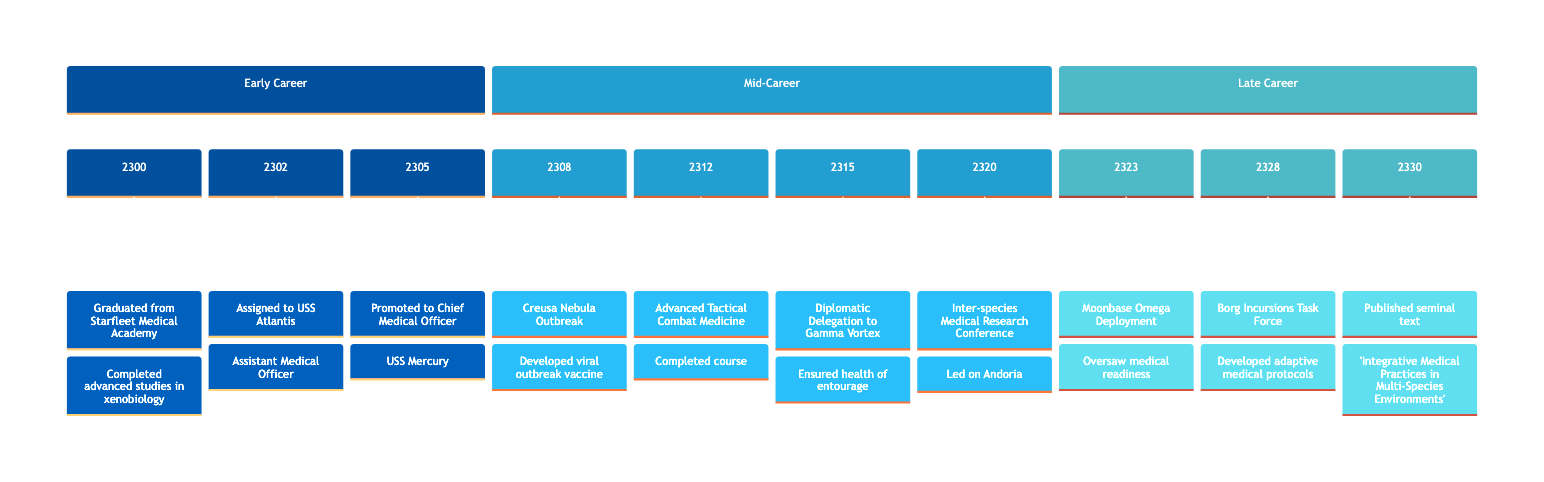What year was the Chief Medical Officer promoted on USS Mercury? The timeline shows that the promotion to Chief Medical Officer occurred in 2305. The event specifically states "Promoted to Chief Medical Officer on USS Mercury" with the corresponding year listed.
Answer: 2305 What major medical intervention happened in 2308? According to the timeline, the key medical intervention in 2308 was the Creusa Nebula Outbreak, where a vaccine was developed to counter the viral outbreak. The timeline explicitly lists this as an event from that year.
Answer: Creusa Nebula Outbreak How many years passed between the graduation and the promotion to Chief Medical Officer? From 2300 to 2305, there are 5 years of progression. The timeline indicates graduation from Starfleet Medical Academy in 2300 and the promotion in 2305. Counting the years gives a clear indication of the time interval.
Answer: 5 years Who was the Chief Medical Officer during the mission to Gamma Vortex? The timeline does not name the individual specifically but indicates that the Chief Medical Officer from 2305 would be responsible during the major mission in 2315. This deduction comes from the event sequence.
Answer: Chief Medical Officer What unique medical protocols were developed in 2328? The timeline explicitly states that in 2328, the Chief Medical Officer developed adaptive medical protocols to deal with injuries from the Borg Collective. This is a significant event noted for that year.
Answer: Adaptive medical protocols How many major events are listed in the late career section? In the late career section of the timeline, three major events are listed: Moonbase Omega Deployment in 2323, Borg Incursions Task Force in 2328, and the publication in 2330. Counting these events confirms the total.
Answer: 3 events What was the focus during the assignment to the USS Atlantis? The role on the USS Atlantis, as noted in 2302, was focused on the research and treatment of injuries during exploratory missions in the Beta Quadrant. This is explicitly stated in the timeline details for that event.
Answer: Research and treatment of injuries What book was published in 2330? The timeline indicates that in 2330, the Chief Medical Officer published “Integrative Medical Practices in Multi-Species Environments.” This title is mentioned directly as an event in that year.
Answer: Integrative Medical Practices in Multi-Species Environments 